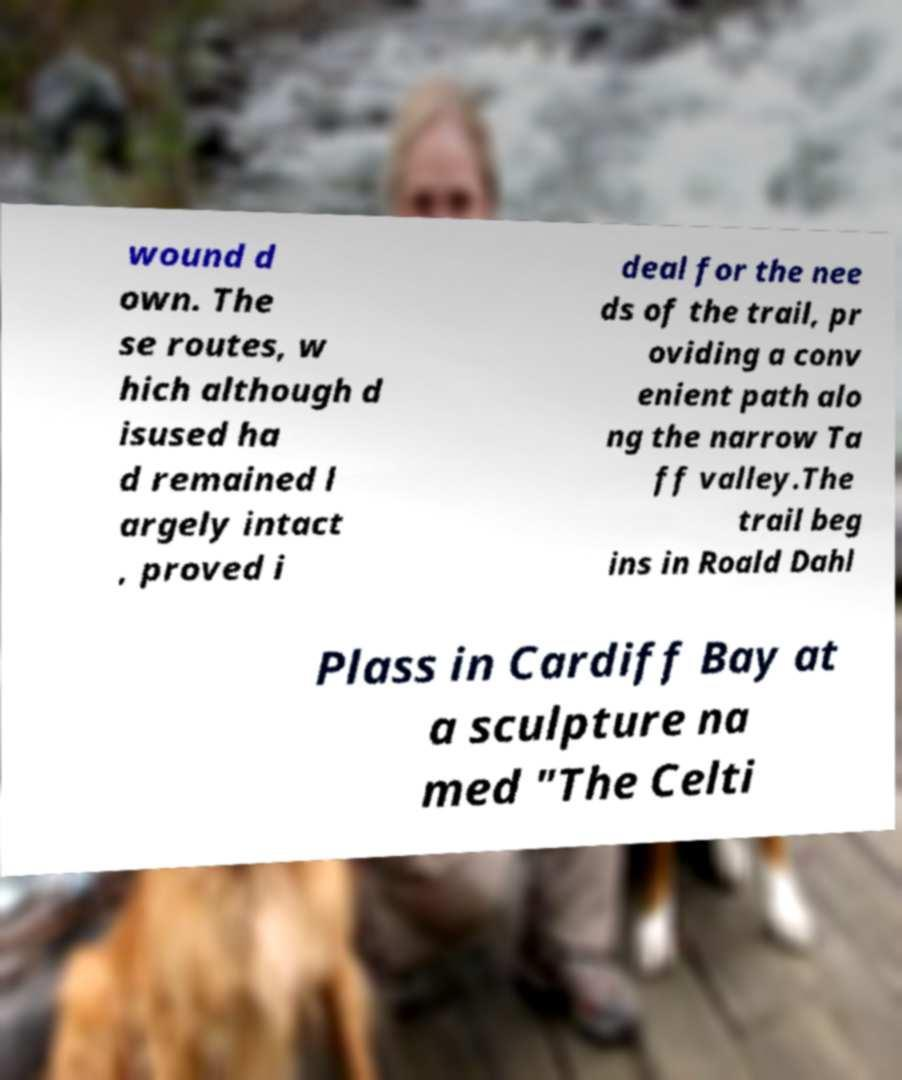Please identify and transcribe the text found in this image. wound d own. The se routes, w hich although d isused ha d remained l argely intact , proved i deal for the nee ds of the trail, pr oviding a conv enient path alo ng the narrow Ta ff valley.The trail beg ins in Roald Dahl Plass in Cardiff Bay at a sculpture na med "The Celti 